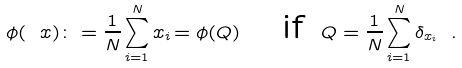Convert formula to latex. <formula><loc_0><loc_0><loc_500><loc_500>\phi ( \ x ) \colon = \frac { 1 } { N } \sum _ { i = 1 } ^ { N } { x _ { i } } { \, = \phi ( Q ) } \quad \text {if } \, Q = \frac { 1 } { N } \sum _ { i = 1 } ^ { N } \delta _ { x _ { i } } \ .</formula> 